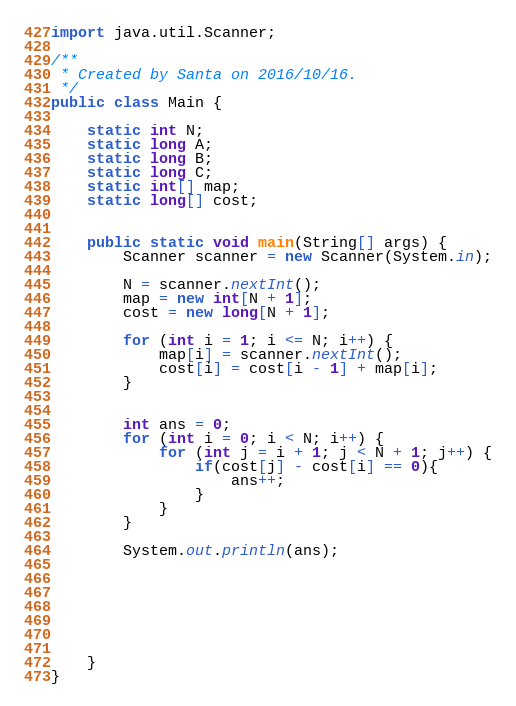Convert code to text. <code><loc_0><loc_0><loc_500><loc_500><_Java_>import java.util.Scanner;

/**
 * Created by Santa on 2016/10/16.
 */
public class Main {

    static int N;
    static long A;
    static long B;
    static long C;
    static int[] map;
    static long[] cost;


    public static void main(String[] args) {
        Scanner scanner = new Scanner(System.in);

        N = scanner.nextInt();
        map = new int[N + 1];
        cost = new long[N + 1];

        for (int i = 1; i <= N; i++) {
            map[i] = scanner.nextInt();
            cost[i] = cost[i - 1] + map[i];
        }


        int ans = 0;
        for (int i = 0; i < N; i++) {
            for (int j = i + 1; j < N + 1; j++) {
                if(cost[j] - cost[i] == 0){
                    ans++;
                }
            }
        }

        System.out.println(ans);







    }
}

</code> 